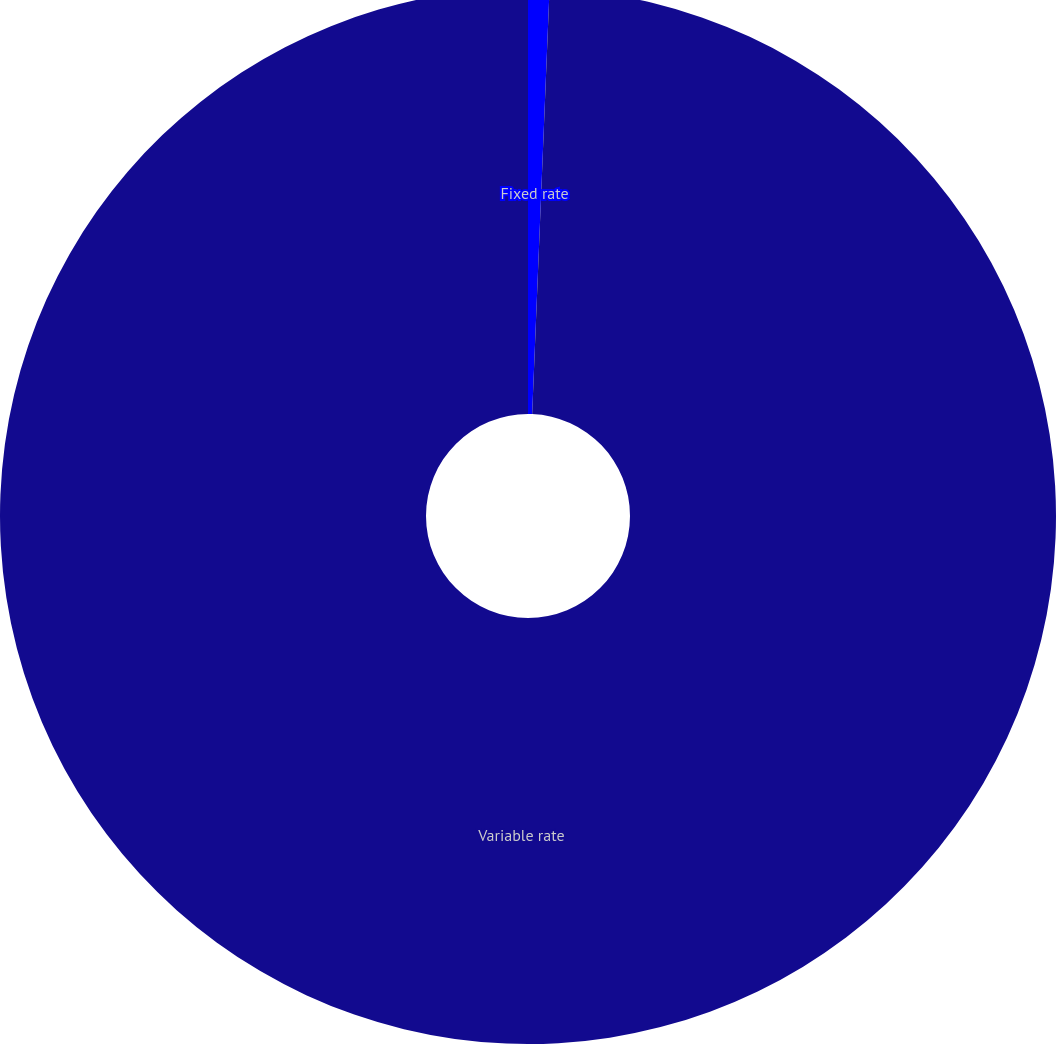Convert chart to OTSL. <chart><loc_0><loc_0><loc_500><loc_500><pie_chart><fcel>Fixed rate<fcel>Variable rate<nl><fcel>0.65%<fcel>99.35%<nl></chart> 